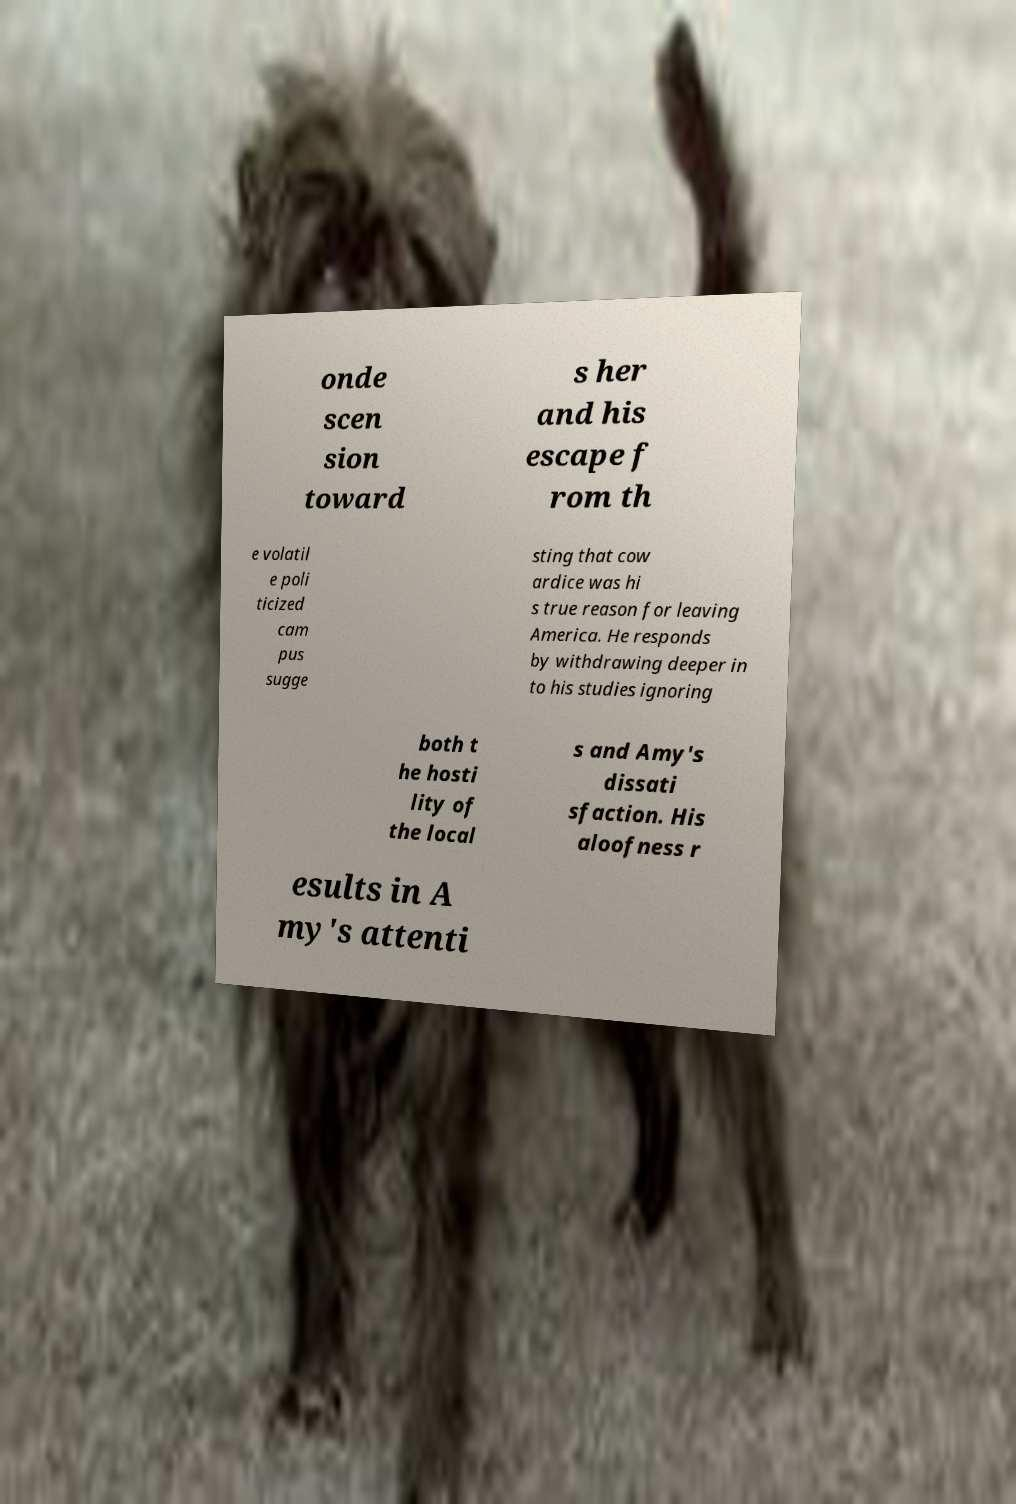Can you read and provide the text displayed in the image?This photo seems to have some interesting text. Can you extract and type it out for me? onde scen sion toward s her and his escape f rom th e volatil e poli ticized cam pus sugge sting that cow ardice was hi s true reason for leaving America. He responds by withdrawing deeper in to his studies ignoring both t he hosti lity of the local s and Amy's dissati sfaction. His aloofness r esults in A my's attenti 